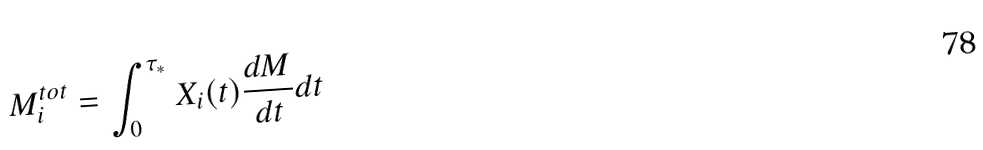Convert formula to latex. <formula><loc_0><loc_0><loc_500><loc_500>M _ { i } ^ { t o t } = \int _ { 0 } ^ { \tau _ { * } } X _ { i } ( t ) \frac { d M } { d t } d t</formula> 